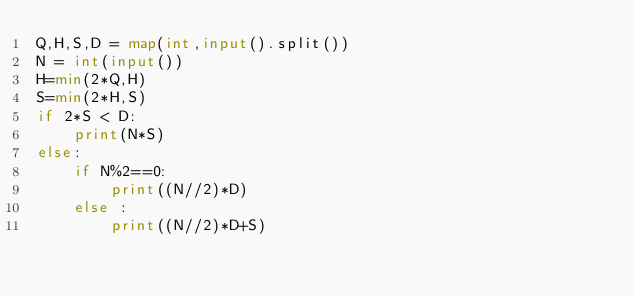<code> <loc_0><loc_0><loc_500><loc_500><_Python_>Q,H,S,D = map(int,input().split())
N = int(input())
H=min(2*Q,H)
S=min(2*H,S)
if 2*S < D:
    print(N*S)
else:
    if N%2==0:
        print((N//2)*D)
    else :
        print((N//2)*D+S)
</code> 